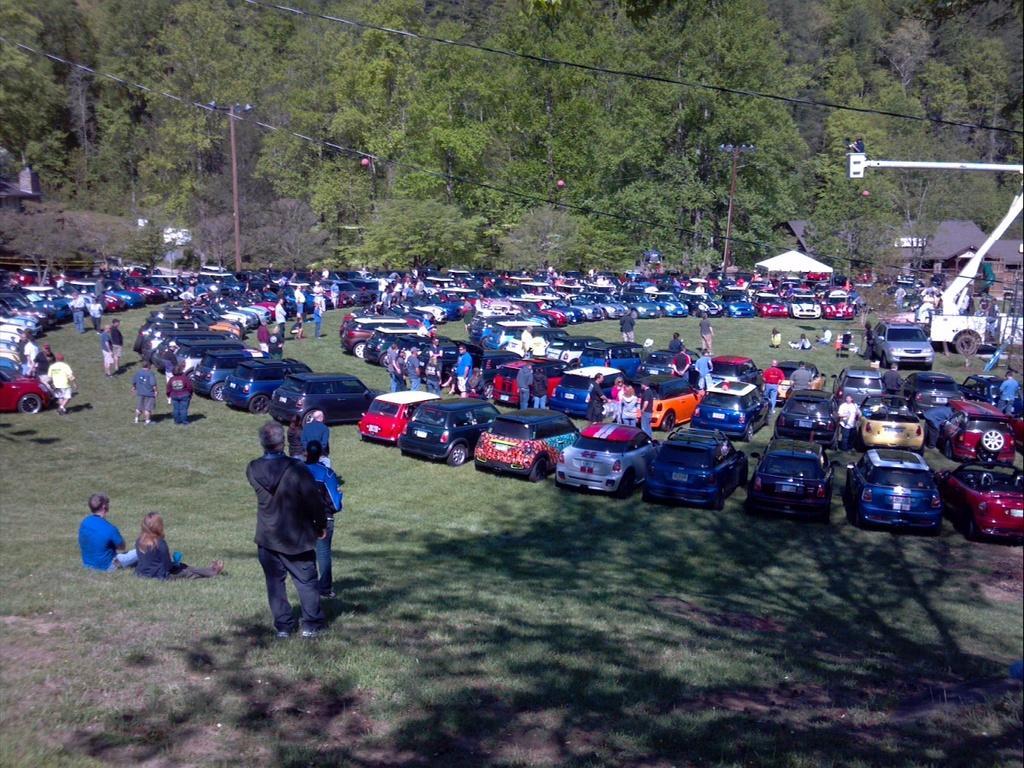Could you give a brief overview of what you see in this image? In this image I can see a ground, on the ground I can see a number of cars parking, in front of the car I can see persons , on the left side I can see two persons sitting on the ground and some of them standing on the ground , at the top I can see trees and tents ,poles and power line cables. 